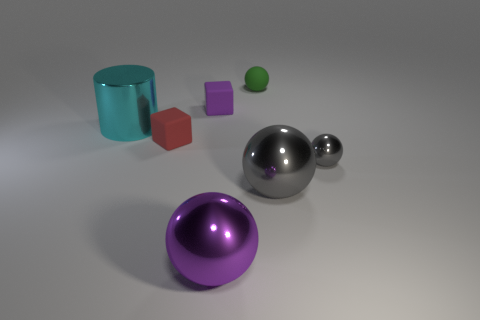Is the size of the gray sphere that is in front of the tiny gray thing the same as the metal object to the left of the large purple sphere?
Keep it short and to the point. Yes. What is the big object that is both to the left of the large gray metallic ball and on the right side of the small purple rubber object made of?
Ensure brevity in your answer.  Metal. The sphere that is the same color as the tiny metal object is what size?
Offer a very short reply. Large. How many other objects are the same size as the green sphere?
Offer a terse response. 3. What is the large object that is behind the small red cube made of?
Give a very brief answer. Metal. Do the purple metal object and the cyan metallic object have the same shape?
Ensure brevity in your answer.  No. How many other objects are there of the same shape as the large purple object?
Ensure brevity in your answer.  3. What color is the big metallic ball to the right of the green ball?
Give a very brief answer. Gray. Is the red thing the same size as the cyan thing?
Keep it short and to the point. No. What material is the big thing that is behind the small shiny thing that is in front of the tiny purple matte thing?
Your response must be concise. Metal. 